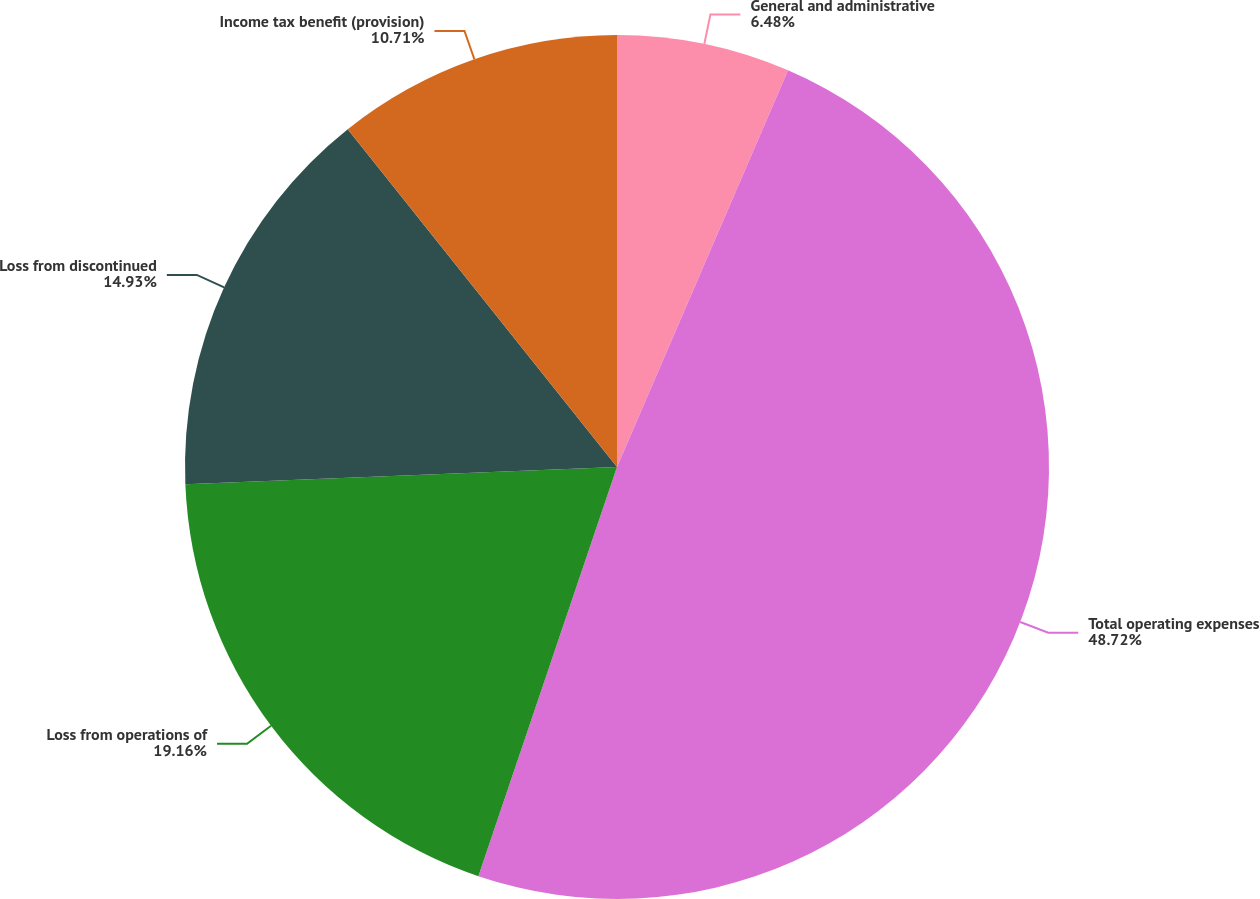Convert chart. <chart><loc_0><loc_0><loc_500><loc_500><pie_chart><fcel>General and administrative<fcel>Total operating expenses<fcel>Loss from operations of<fcel>Loss from discontinued<fcel>Income tax benefit (provision)<nl><fcel>6.48%<fcel>48.72%<fcel>19.16%<fcel>14.93%<fcel>10.71%<nl></chart> 